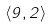Convert formula to latex. <formula><loc_0><loc_0><loc_500><loc_500>\langle 9 , 2 \rangle</formula> 